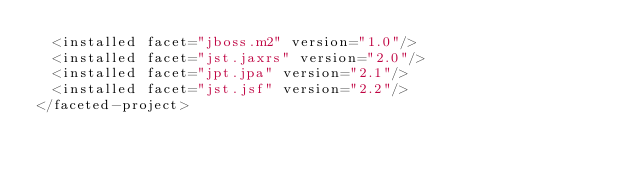Convert code to text. <code><loc_0><loc_0><loc_500><loc_500><_XML_>  <installed facet="jboss.m2" version="1.0"/>
  <installed facet="jst.jaxrs" version="2.0"/>
  <installed facet="jpt.jpa" version="2.1"/>
  <installed facet="jst.jsf" version="2.2"/>
</faceted-project>
</code> 